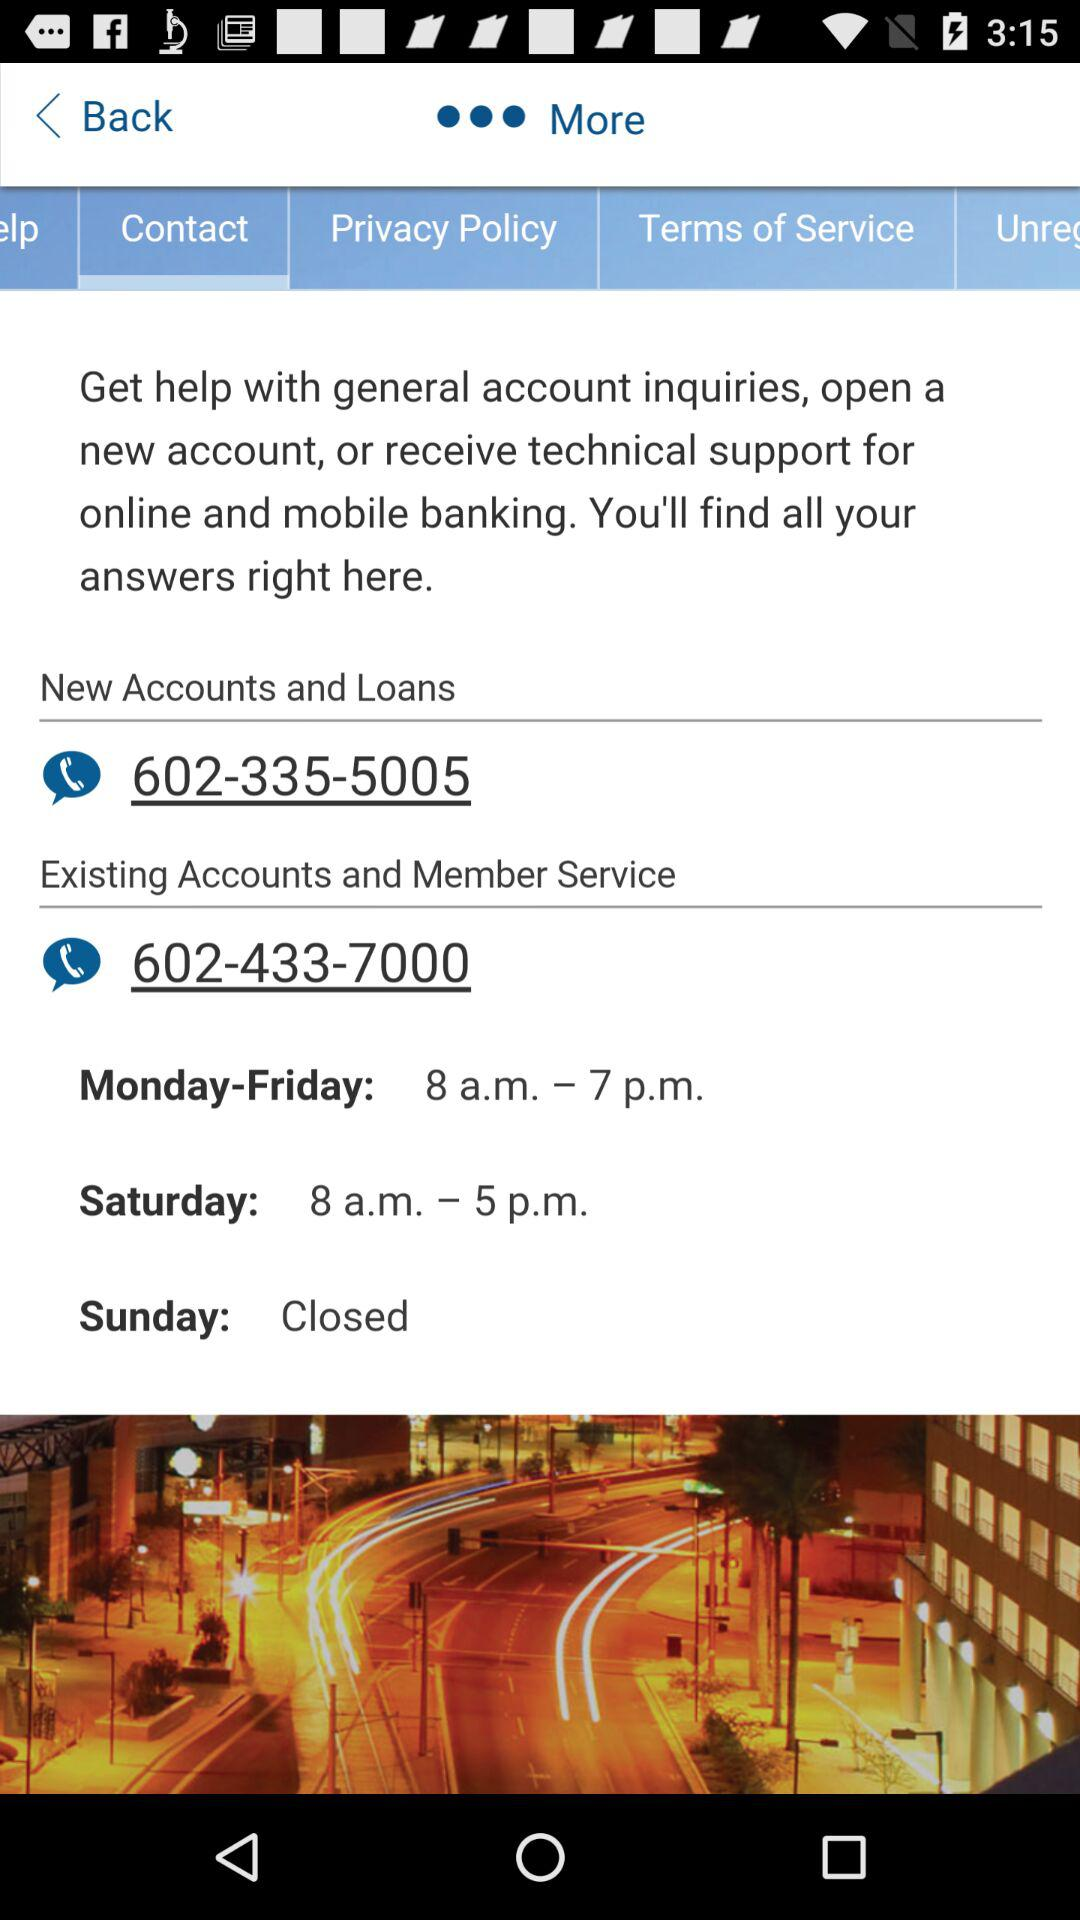Which day of the week is the member service closed? The member service is closed on Sunday. 